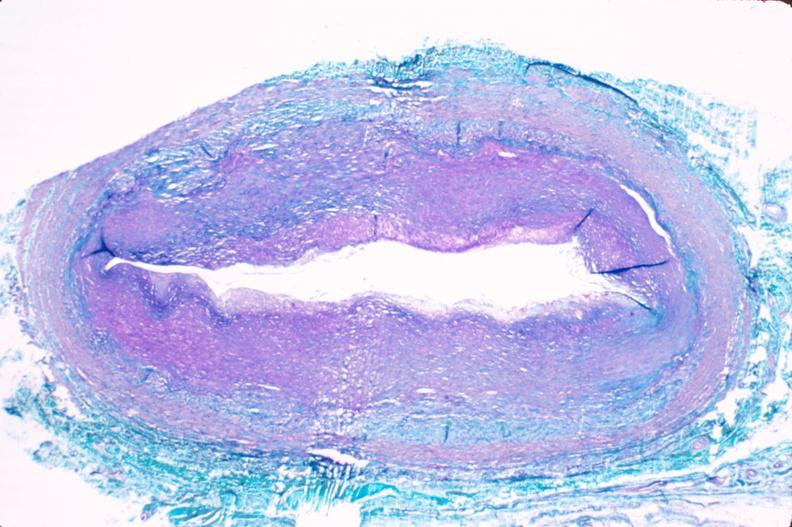what is present?
Answer the question using a single word or phrase. Cardiovascular 